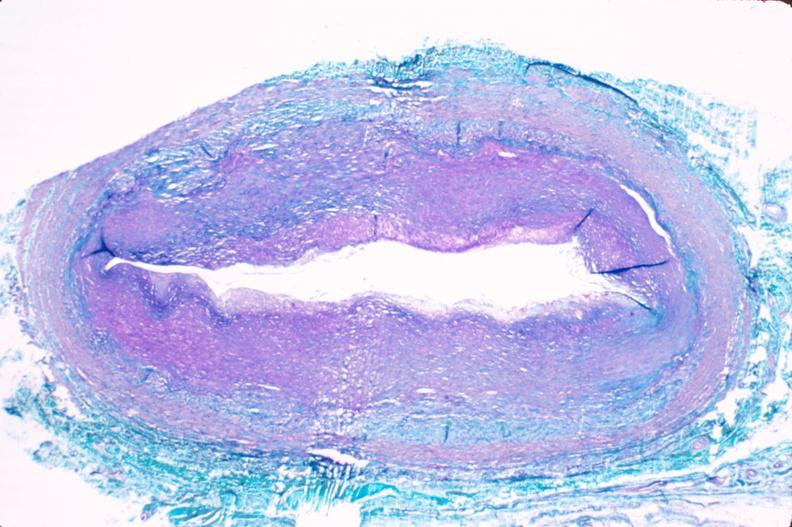what is present?
Answer the question using a single word or phrase. Cardiovascular 